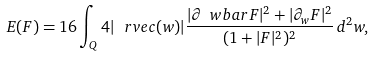Convert formula to latex. <formula><loc_0><loc_0><loc_500><loc_500>E ( F ) = 1 6 \int _ { Q } 4 | \ r v e c ( w ) | \frac { | \partial _ { \ } w b a r F | ^ { 2 } + | \partial _ { w } F | ^ { 2 } } { ( 1 + | F | ^ { 2 } ) ^ { 2 } } \, d ^ { 2 } w ,</formula> 